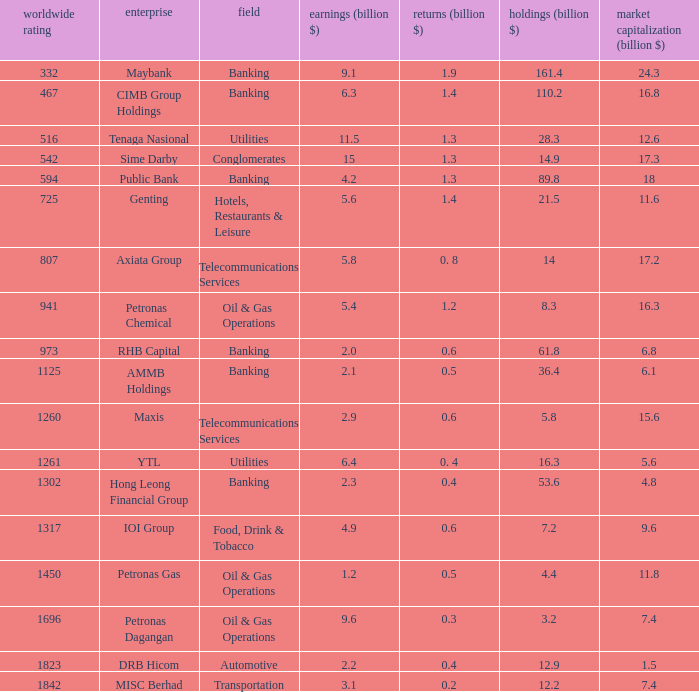Name the total number of industry for maxis 1.0. 